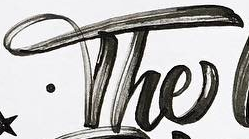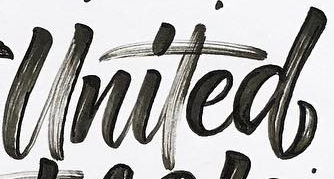Read the text from these images in sequence, separated by a semicolon. The; United 